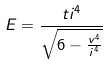<formula> <loc_0><loc_0><loc_500><loc_500>E = \frac { t i ^ { 4 } } { \sqrt { 6 - \frac { v ^ { 4 } } { i ^ { 4 } } } }</formula> 